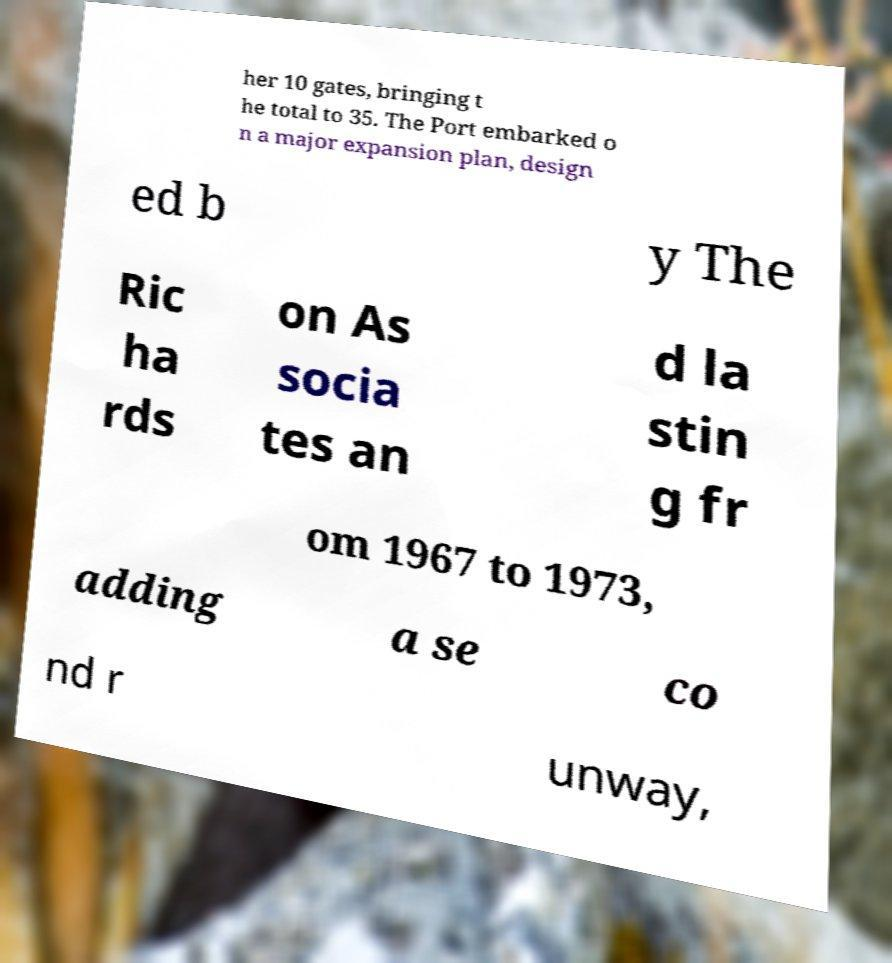There's text embedded in this image that I need extracted. Can you transcribe it verbatim? her 10 gates, bringing t he total to 35. The Port embarked o n a major expansion plan, design ed b y The Ric ha rds on As socia tes an d la stin g fr om 1967 to 1973, adding a se co nd r unway, 